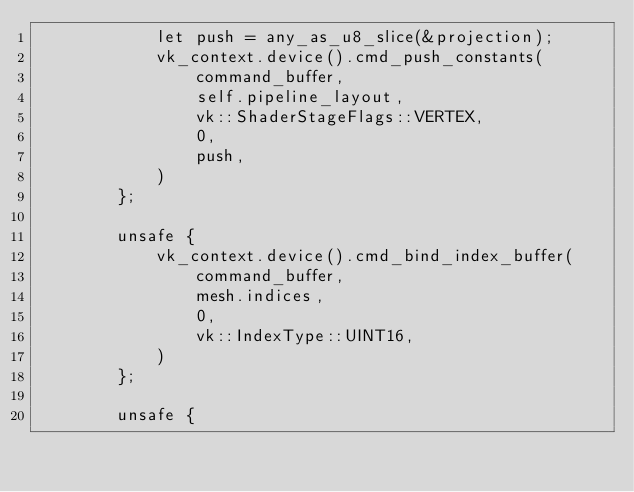Convert code to text. <code><loc_0><loc_0><loc_500><loc_500><_Rust_>            let push = any_as_u8_slice(&projection);
            vk_context.device().cmd_push_constants(
                command_buffer,
                self.pipeline_layout,
                vk::ShaderStageFlags::VERTEX,
                0,
                push,
            )
        };

        unsafe {
            vk_context.device().cmd_bind_index_buffer(
                command_buffer,
                mesh.indices,
                0,
                vk::IndexType::UINT16,
            )
        };

        unsafe {</code> 